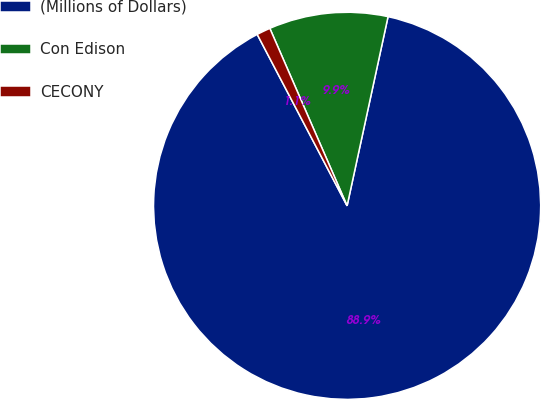Convert chart. <chart><loc_0><loc_0><loc_500><loc_500><pie_chart><fcel>(Millions of Dollars)<fcel>Con Edison<fcel>CECONY<nl><fcel>88.93%<fcel>9.93%<fcel>1.15%<nl></chart> 